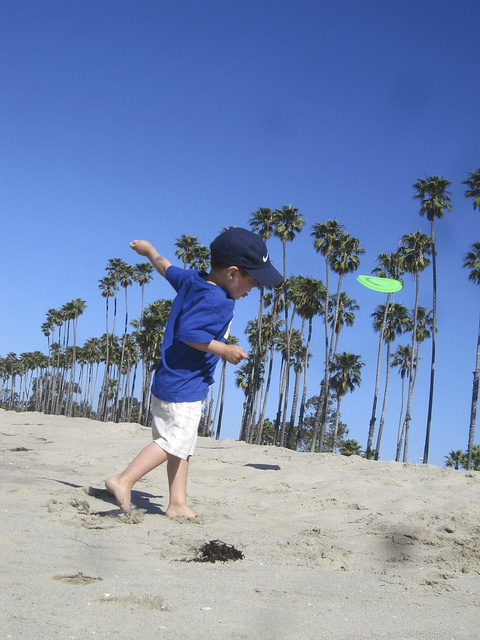Describe the objects in this image and their specific colors. I can see people in blue, navy, white, and black tones and frisbee in blue, lightgreen, darkgray, and teal tones in this image. 